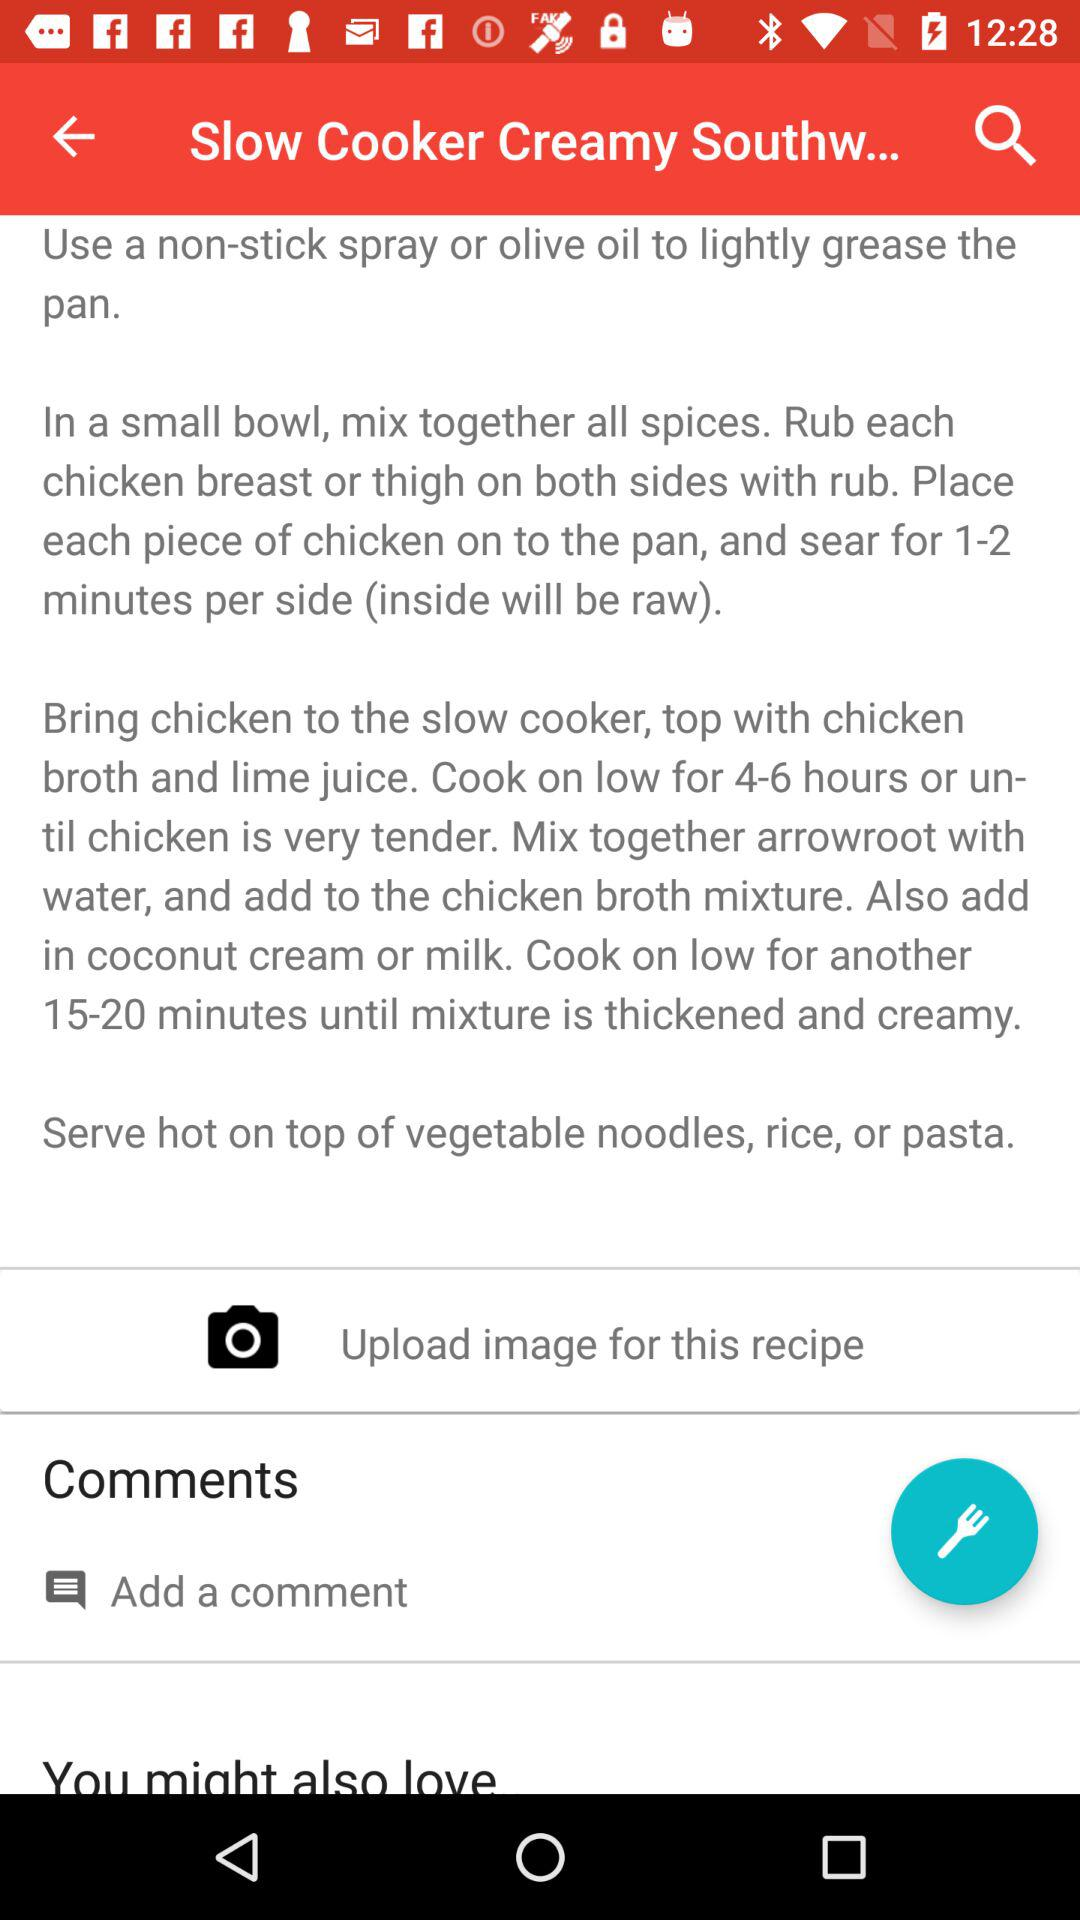What things are used for serving with the recipe? The things that are used for serving with the recipe are vegetable noodles, rice or pasta. 